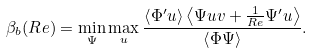<formula> <loc_0><loc_0><loc_500><loc_500>\beta _ { b } ( R e ) = \min _ { \Psi } \max _ { u } \frac { \left < \Phi ^ { \prime } u \right > \left < \Psi u v + \frac { 1 } { R e } \Psi ^ { \prime } u \right > } { \left < \Phi \Psi \right > } .</formula> 